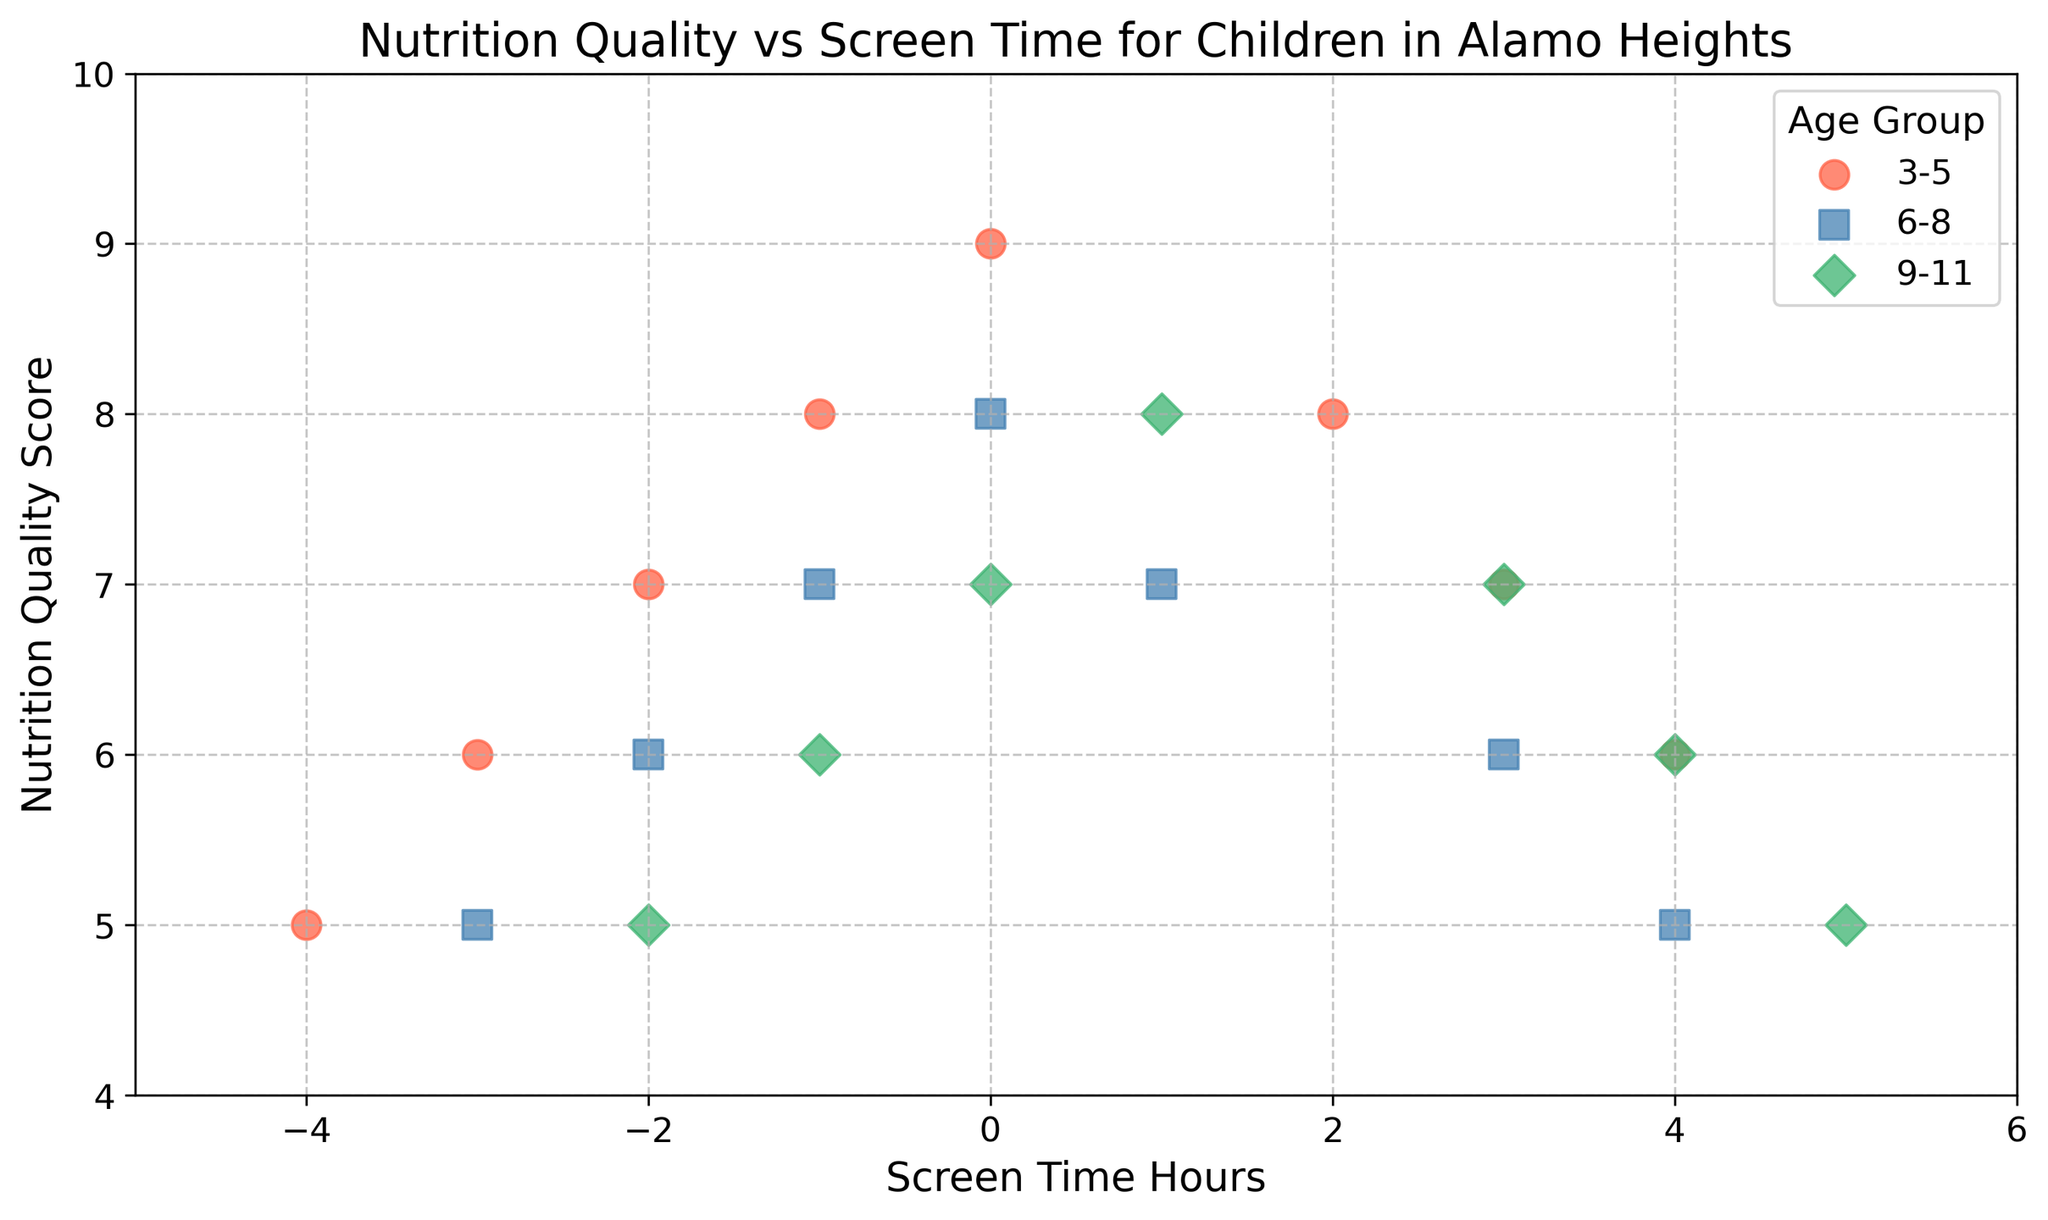What's the average Nutrition Quality Score for the 3-5 age group? First, identify the Nutrition Quality Scores for the 3-5 age group: 5, 6, 7, 8, 9, 8, 7, 6. Sum these values: 5 + 6 + 7 + 8 + 9 + 8 + 7 + 6 = 56. Divide by the number of data points (8): 56 / 8 = 7
Answer: 7 For which age group is the trend between Nutrition Quality Score and Screen Time most negative? Analyze the trends: In the 3-5 age group, the Nutrition Quality Score decreases as Screen Time increases from -4 to 4. The 6-8 and 9-11 groups also show decline but the slope appears less steep. The 3-5 age group shows the most negative trend.
Answer: 3-5 What is the common Nutrition Quality Score across all age groups? By scanning the data points visually across all age groups, the Nutrition Quality Score '7' appears for each group: 3-5, 6-8, and 9-11.
Answer: 7 Which age group has the widest range of Screen Time Hours? Identify the range of Screen Time Hours for each age group: 3-5 is -4 to 4, 6-8 is -3 to 4, and 9-11 is -2 to 5. The 3-5 age group has the widest range (spread from -4 to 4, a difference of 8).
Answer: 3-5 How does Screen Time affect Nutrition Quality Score for the 6-8 age group? Observe the scatter plot points for the 6-8 age group: As Screen Time Hours go from -3 to 4, the Nutrition Quality Score starts high (8) and then gradually decreases (to 5), indicating a negative correlation.
Answer: Negatively Which age group has no points in the negative Screen Time range? Review each age group: 3-5 (negative range: -4 to -1), 6-8 (negative range: -3 to -1), 9-11 (negative range: -2 to -1). Since 9-11 has data points only from -2 to 5, it has points in the negative range. So all groups have points in the negative range.
Answer: None Which color represents the 6-8 age group? Identify the color used in the scatter plot for the 6-8 age group, marked with a specific color. The color for 6-8 is blue.
Answer: Blue At what Screen Time Hours do children in the age group 9-11 have a Nutrition Quality Score of 6? Find the data points for the 9-11 age group and look for Nutrition Quality Scores of 6. They occur at Screen Time Hours -1 and 4.
Answer: -1, 4 Which age group's data points primarily fall in positive Screen Time Hours? Review the scatter plot to see where each age group's points lie. The ages 9-11 mostly fall in the positive Screen Time range from 0 to 5.
Answer: 9-11 For the age group 3-5, what is the difference in Nutrition Quality Score between the maximum Screen Time Hour and the minimum Screen Time Hour? For 3-5, the minimum Screen Time Hour is -4 with Nutrition Quality Score 5 and the maximum is 4 with a score of 6. Difference = 6 - 5 = 1
Answer: 1 